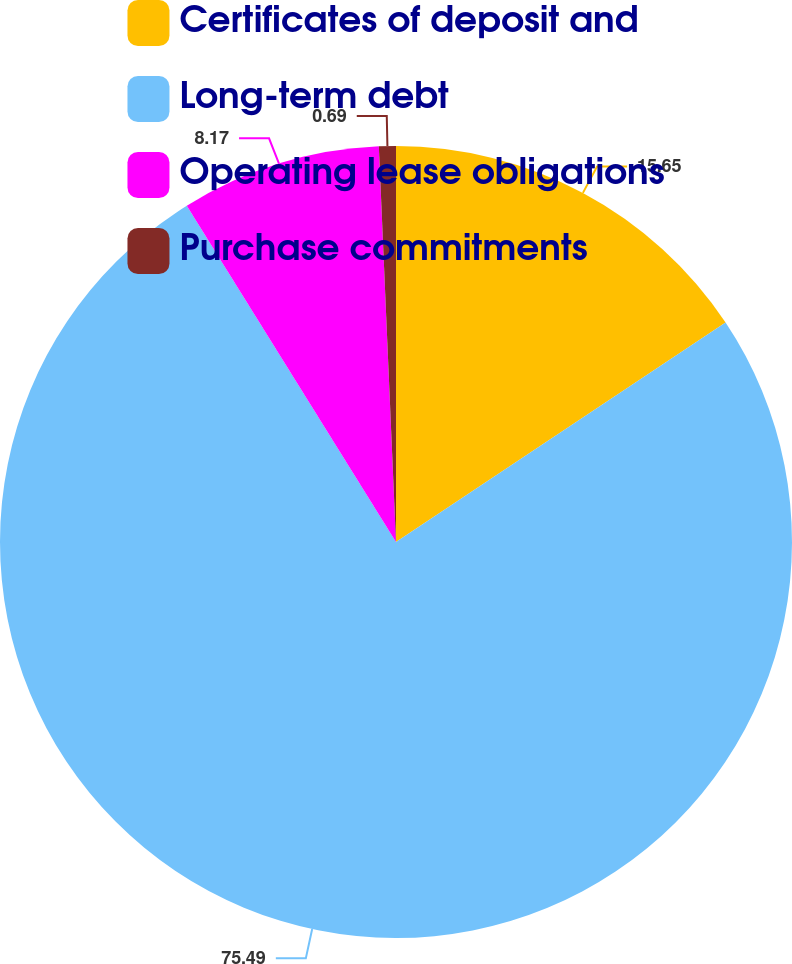<chart> <loc_0><loc_0><loc_500><loc_500><pie_chart><fcel>Certificates of deposit and<fcel>Long-term debt<fcel>Operating lease obligations<fcel>Purchase commitments<nl><fcel>15.65%<fcel>75.5%<fcel>8.17%<fcel>0.69%<nl></chart> 